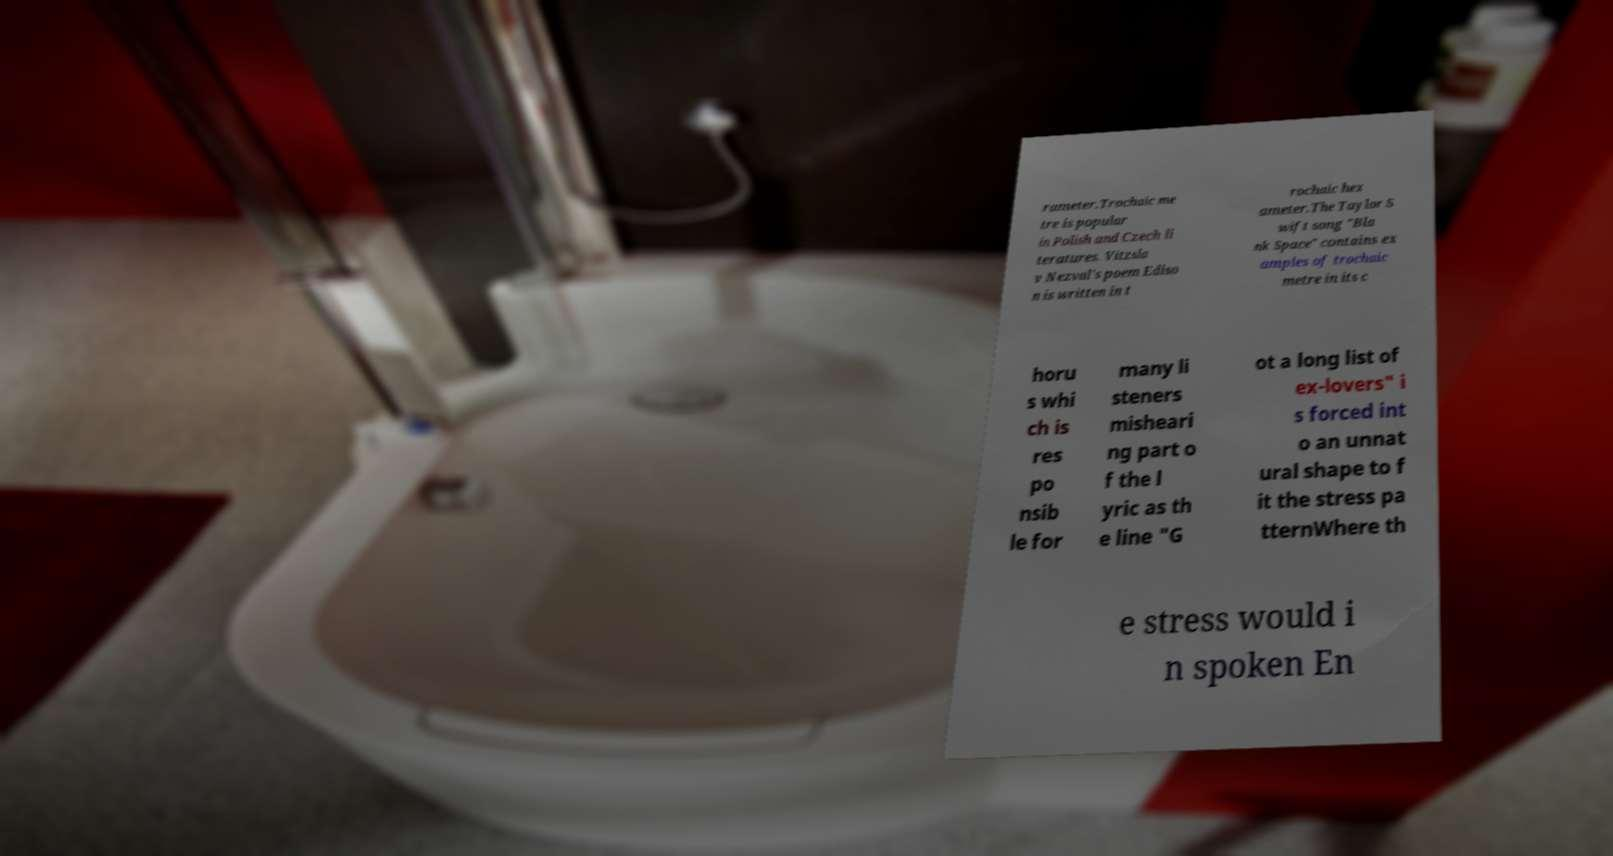Could you assist in decoding the text presented in this image and type it out clearly? rameter.Trochaic me tre is popular in Polish and Czech li teratures. Vitzsla v Nezval's poem Ediso n is written in t rochaic hex ameter.The Taylor S wift song "Bla nk Space" contains ex amples of trochaic metre in its c horu s whi ch is res po nsib le for many li steners misheari ng part o f the l yric as th e line "G ot a long list of ex-lovers" i s forced int o an unnat ural shape to f it the stress pa tternWhere th e stress would i n spoken En 